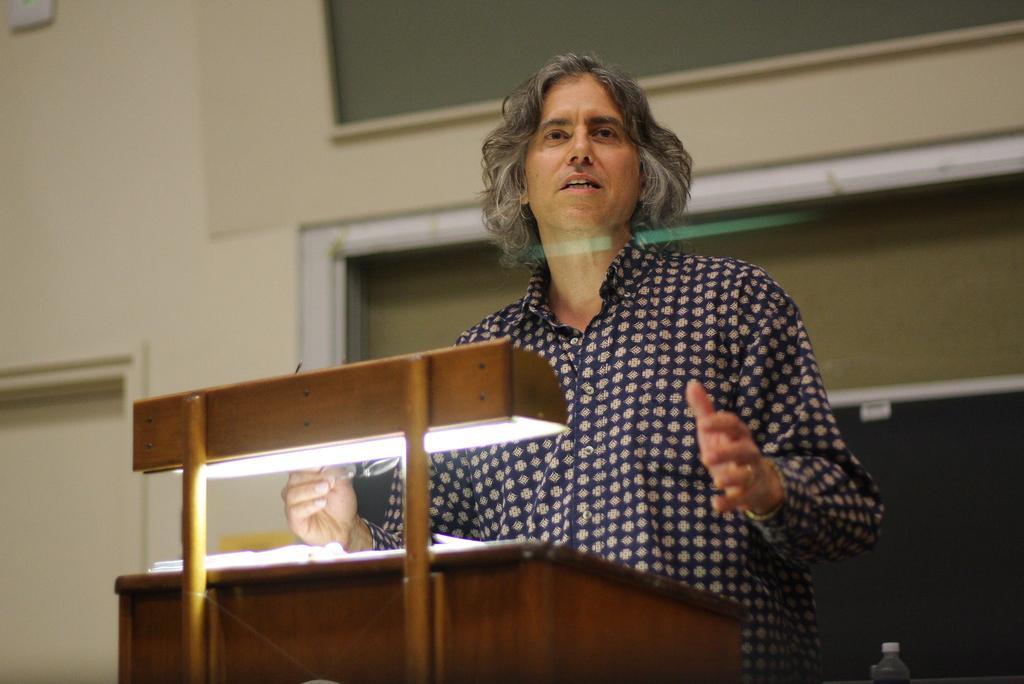Can you describe this image briefly? In this image, there is a person wearing clothes and standing in front of the podium. 